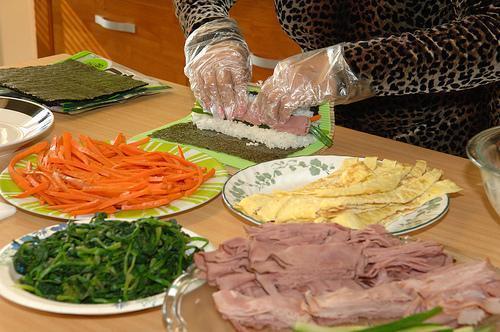How many women are in the kitchen?
Give a very brief answer. 1. 